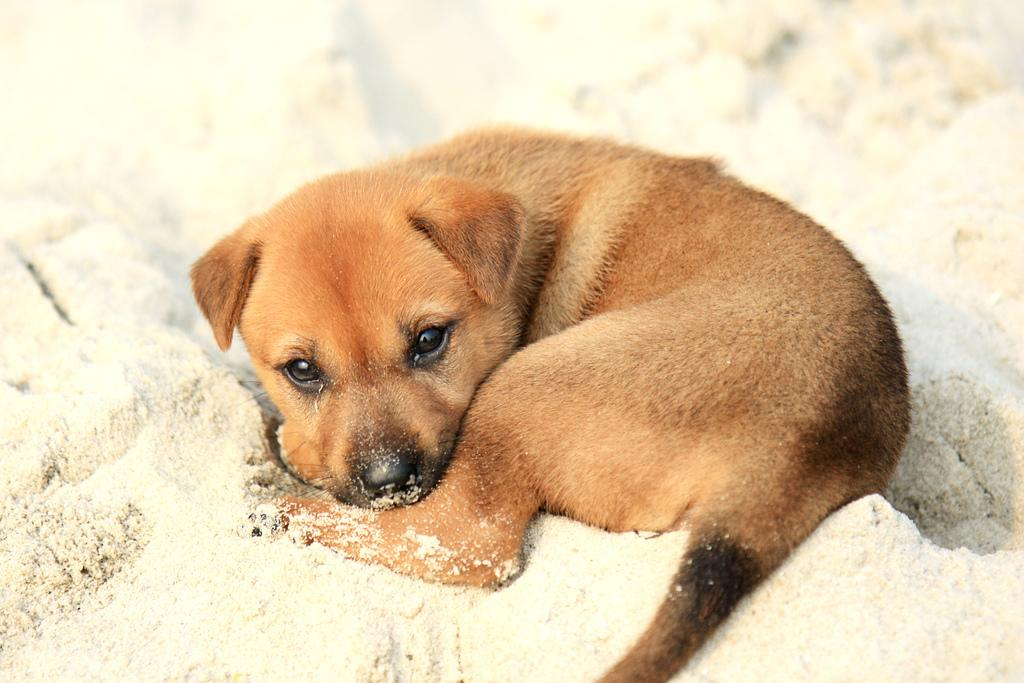What animal can be seen in the image? There is a dog in the image. Where is the dog located? The dog is on the sand. What type of skin condition does the dog have in the image? There is no indication of any skin condition on the dog in the image. What list is the dog a part of in the image? There is no list mentioned or implied in the image. 